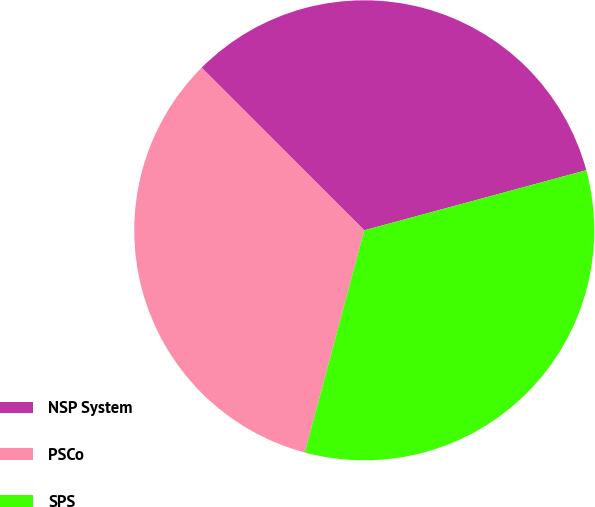Convert chart. <chart><loc_0><loc_0><loc_500><loc_500><pie_chart><fcel>NSP System<fcel>PSCo<fcel>SPS<nl><fcel>33.3%<fcel>33.33%<fcel>33.37%<nl></chart> 